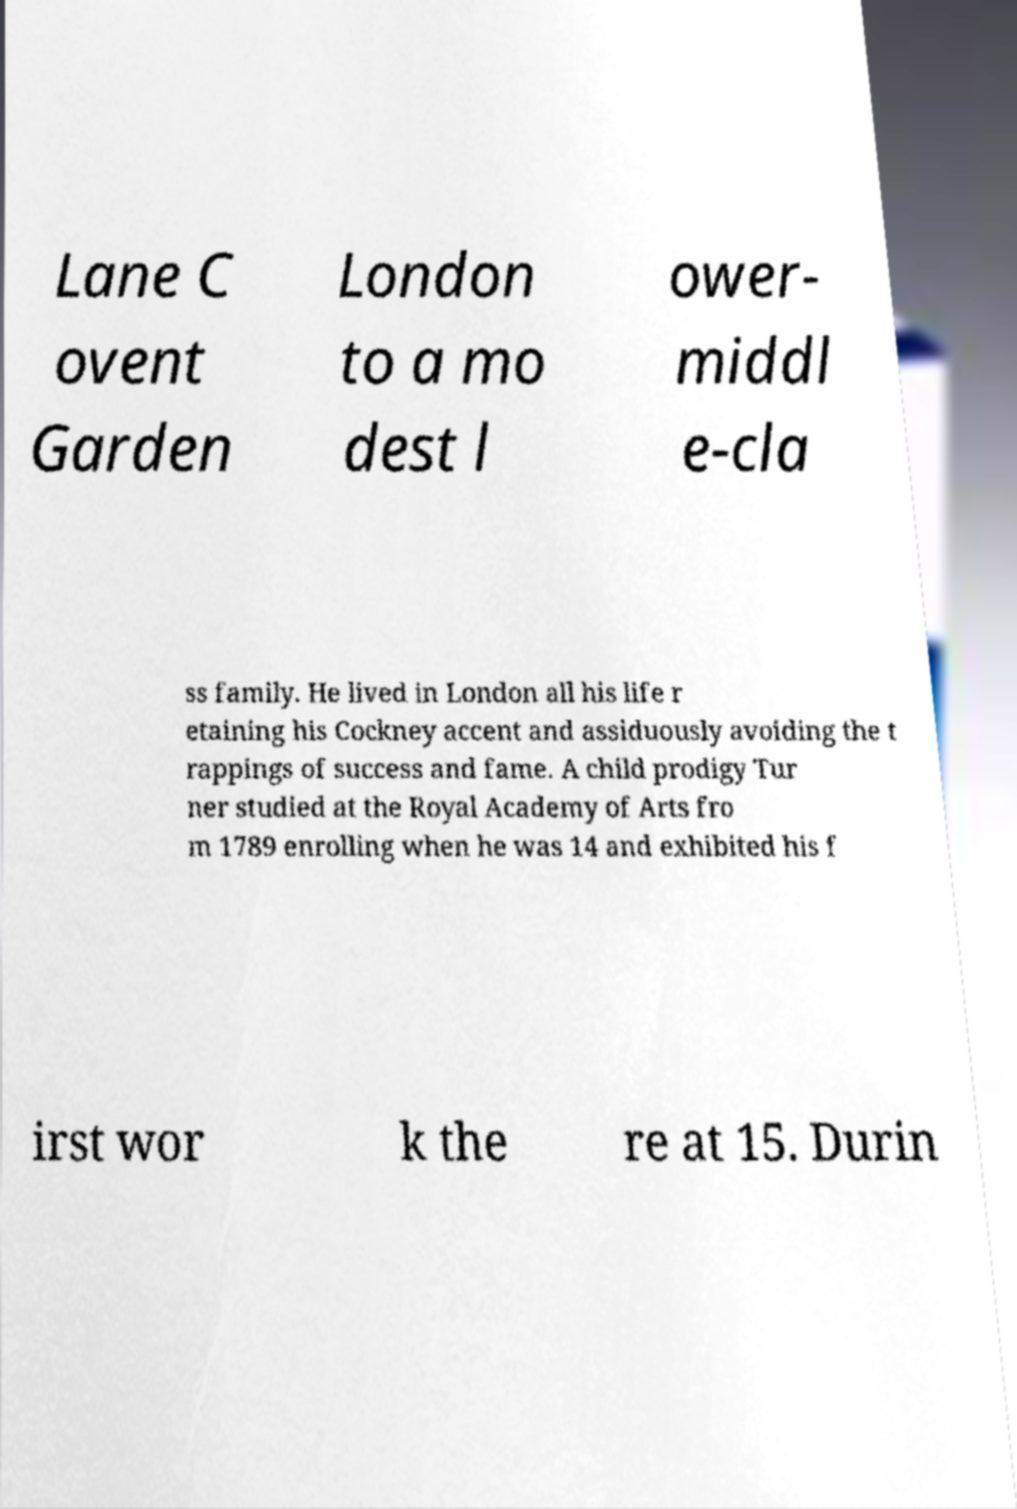Could you extract and type out the text from this image? Lane C ovent Garden London to a mo dest l ower- middl e-cla ss family. He lived in London all his life r etaining his Cockney accent and assiduously avoiding the t rappings of success and fame. A child prodigy Tur ner studied at the Royal Academy of Arts fro m 1789 enrolling when he was 14 and exhibited his f irst wor k the re at 15. Durin 